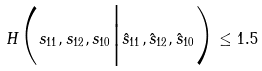<formula> <loc_0><loc_0><loc_500><loc_500>H \Big ( s _ { 1 1 } , s _ { 1 2 } , s _ { 1 0 } \Big | \hat { s } _ { 1 1 } , \hat { s } _ { 1 2 } , \hat { s } _ { 1 0 } \Big ) \leq 1 . 5</formula> 